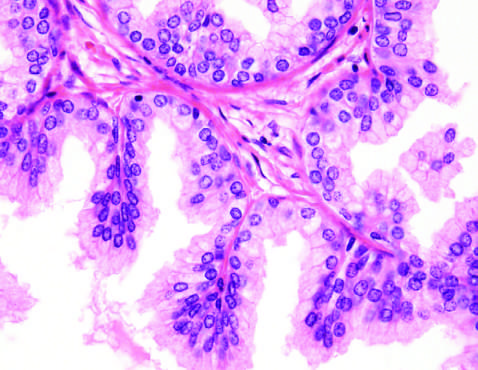how does low-power photomicrograph demonstrate a well-demarcated nodule at the right of the field?
Answer the question using a single word or phrase. With a portion of urethra seen to the left 